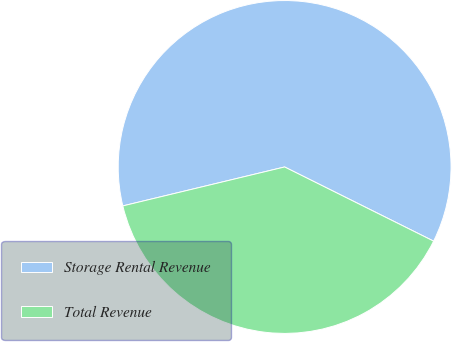<chart> <loc_0><loc_0><loc_500><loc_500><pie_chart><fcel>Storage Rental Revenue<fcel>Total Revenue<nl><fcel>61.11%<fcel>38.89%<nl></chart> 